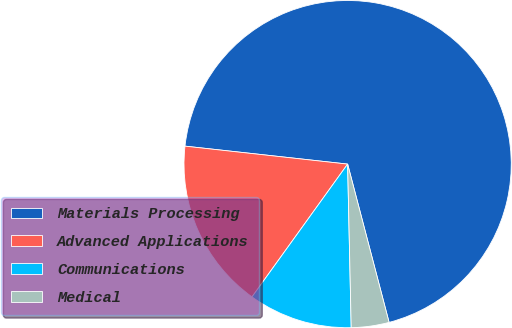<chart> <loc_0><loc_0><loc_500><loc_500><pie_chart><fcel>Materials Processing<fcel>Advanced Applications<fcel>Communications<fcel>Medical<nl><fcel>69.17%<fcel>16.82%<fcel>10.28%<fcel>3.73%<nl></chart> 